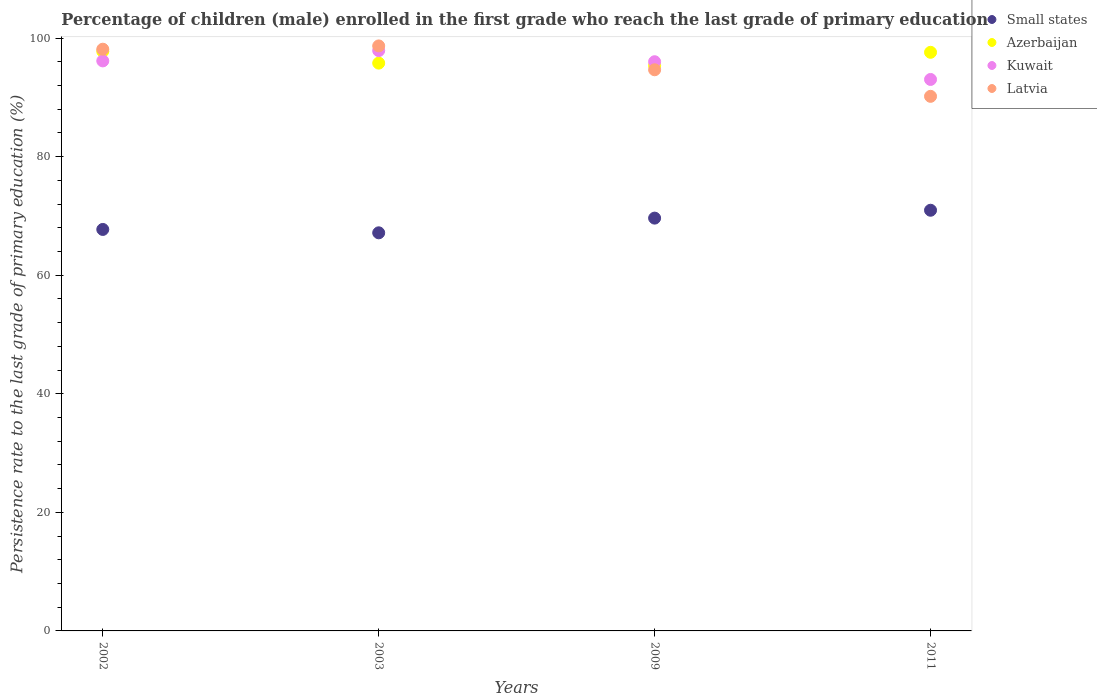Is the number of dotlines equal to the number of legend labels?
Offer a very short reply. Yes. What is the persistence rate of children in Kuwait in 2003?
Offer a terse response. 97.89. Across all years, what is the maximum persistence rate of children in Latvia?
Ensure brevity in your answer.  98.68. Across all years, what is the minimum persistence rate of children in Small states?
Your response must be concise. 67.15. In which year was the persistence rate of children in Azerbaijan maximum?
Ensure brevity in your answer.  2002. What is the total persistence rate of children in Azerbaijan in the graph?
Offer a terse response. 386.53. What is the difference between the persistence rate of children in Azerbaijan in 2002 and that in 2009?
Make the answer very short. 2.39. What is the difference between the persistence rate of children in Kuwait in 2002 and the persistence rate of children in Small states in 2009?
Your response must be concise. 26.52. What is the average persistence rate of children in Azerbaijan per year?
Offer a terse response. 96.63. In the year 2009, what is the difference between the persistence rate of children in Latvia and persistence rate of children in Kuwait?
Keep it short and to the point. -1.36. What is the ratio of the persistence rate of children in Azerbaijan in 2003 to that in 2009?
Ensure brevity in your answer.  1. Is the difference between the persistence rate of children in Latvia in 2002 and 2003 greater than the difference between the persistence rate of children in Kuwait in 2002 and 2003?
Offer a terse response. Yes. What is the difference between the highest and the second highest persistence rate of children in Kuwait?
Your answer should be compact. 1.74. What is the difference between the highest and the lowest persistence rate of children in Kuwait?
Your answer should be very brief. 4.87. In how many years, is the persistence rate of children in Small states greater than the average persistence rate of children in Small states taken over all years?
Your response must be concise. 2. Is the sum of the persistence rate of children in Kuwait in 2002 and 2003 greater than the maximum persistence rate of children in Latvia across all years?
Your answer should be compact. Yes. Is it the case that in every year, the sum of the persistence rate of children in Latvia and persistence rate of children in Azerbaijan  is greater than the sum of persistence rate of children in Kuwait and persistence rate of children in Small states?
Your answer should be very brief. No. Is it the case that in every year, the sum of the persistence rate of children in Kuwait and persistence rate of children in Latvia  is greater than the persistence rate of children in Small states?
Ensure brevity in your answer.  Yes. How many dotlines are there?
Give a very brief answer. 4. Are the values on the major ticks of Y-axis written in scientific E-notation?
Offer a very short reply. No. Does the graph contain any zero values?
Provide a succinct answer. No. How are the legend labels stacked?
Provide a short and direct response. Vertical. What is the title of the graph?
Your answer should be compact. Percentage of children (male) enrolled in the first grade who reach the last grade of primary education. Does "Slovenia" appear as one of the legend labels in the graph?
Give a very brief answer. No. What is the label or title of the Y-axis?
Give a very brief answer. Persistence rate to the last grade of primary education (%). What is the Persistence rate to the last grade of primary education (%) of Small states in 2002?
Provide a short and direct response. 67.72. What is the Persistence rate to the last grade of primary education (%) of Azerbaijan in 2002?
Your answer should be very brief. 97.77. What is the Persistence rate to the last grade of primary education (%) in Kuwait in 2002?
Offer a terse response. 96.15. What is the Persistence rate to the last grade of primary education (%) of Latvia in 2002?
Your answer should be compact. 98.13. What is the Persistence rate to the last grade of primary education (%) in Small states in 2003?
Provide a short and direct response. 67.15. What is the Persistence rate to the last grade of primary education (%) in Azerbaijan in 2003?
Your answer should be very brief. 95.78. What is the Persistence rate to the last grade of primary education (%) in Kuwait in 2003?
Your answer should be compact. 97.89. What is the Persistence rate to the last grade of primary education (%) in Latvia in 2003?
Offer a very short reply. 98.68. What is the Persistence rate to the last grade of primary education (%) of Small states in 2009?
Provide a succinct answer. 69.63. What is the Persistence rate to the last grade of primary education (%) in Azerbaijan in 2009?
Make the answer very short. 95.38. What is the Persistence rate to the last grade of primary education (%) of Kuwait in 2009?
Offer a very short reply. 96.02. What is the Persistence rate to the last grade of primary education (%) of Latvia in 2009?
Provide a succinct answer. 94.66. What is the Persistence rate to the last grade of primary education (%) of Small states in 2011?
Your answer should be compact. 70.96. What is the Persistence rate to the last grade of primary education (%) of Azerbaijan in 2011?
Provide a succinct answer. 97.6. What is the Persistence rate to the last grade of primary education (%) of Kuwait in 2011?
Offer a very short reply. 93.02. What is the Persistence rate to the last grade of primary education (%) of Latvia in 2011?
Ensure brevity in your answer.  90.18. Across all years, what is the maximum Persistence rate to the last grade of primary education (%) of Small states?
Give a very brief answer. 70.96. Across all years, what is the maximum Persistence rate to the last grade of primary education (%) in Azerbaijan?
Your answer should be very brief. 97.77. Across all years, what is the maximum Persistence rate to the last grade of primary education (%) in Kuwait?
Your answer should be compact. 97.89. Across all years, what is the maximum Persistence rate to the last grade of primary education (%) of Latvia?
Provide a short and direct response. 98.68. Across all years, what is the minimum Persistence rate to the last grade of primary education (%) of Small states?
Offer a very short reply. 67.15. Across all years, what is the minimum Persistence rate to the last grade of primary education (%) in Azerbaijan?
Provide a short and direct response. 95.38. Across all years, what is the minimum Persistence rate to the last grade of primary education (%) in Kuwait?
Give a very brief answer. 93.02. Across all years, what is the minimum Persistence rate to the last grade of primary education (%) in Latvia?
Ensure brevity in your answer.  90.18. What is the total Persistence rate to the last grade of primary education (%) in Small states in the graph?
Keep it short and to the point. 275.47. What is the total Persistence rate to the last grade of primary education (%) in Azerbaijan in the graph?
Ensure brevity in your answer.  386.53. What is the total Persistence rate to the last grade of primary education (%) of Kuwait in the graph?
Your answer should be compact. 383.08. What is the total Persistence rate to the last grade of primary education (%) in Latvia in the graph?
Offer a terse response. 381.64. What is the difference between the Persistence rate to the last grade of primary education (%) of Small states in 2002 and that in 2003?
Provide a succinct answer. 0.57. What is the difference between the Persistence rate to the last grade of primary education (%) in Azerbaijan in 2002 and that in 2003?
Ensure brevity in your answer.  1.99. What is the difference between the Persistence rate to the last grade of primary education (%) in Kuwait in 2002 and that in 2003?
Offer a very short reply. -1.74. What is the difference between the Persistence rate to the last grade of primary education (%) in Latvia in 2002 and that in 2003?
Keep it short and to the point. -0.55. What is the difference between the Persistence rate to the last grade of primary education (%) of Small states in 2002 and that in 2009?
Your answer should be very brief. -1.91. What is the difference between the Persistence rate to the last grade of primary education (%) in Azerbaijan in 2002 and that in 2009?
Offer a terse response. 2.39. What is the difference between the Persistence rate to the last grade of primary education (%) of Kuwait in 2002 and that in 2009?
Your answer should be very brief. 0.14. What is the difference between the Persistence rate to the last grade of primary education (%) in Latvia in 2002 and that in 2009?
Offer a terse response. 3.47. What is the difference between the Persistence rate to the last grade of primary education (%) in Small states in 2002 and that in 2011?
Your answer should be compact. -3.24. What is the difference between the Persistence rate to the last grade of primary education (%) in Azerbaijan in 2002 and that in 2011?
Offer a very short reply. 0.16. What is the difference between the Persistence rate to the last grade of primary education (%) in Kuwait in 2002 and that in 2011?
Provide a succinct answer. 3.13. What is the difference between the Persistence rate to the last grade of primary education (%) of Latvia in 2002 and that in 2011?
Offer a very short reply. 7.95. What is the difference between the Persistence rate to the last grade of primary education (%) of Small states in 2003 and that in 2009?
Your answer should be very brief. -2.48. What is the difference between the Persistence rate to the last grade of primary education (%) in Azerbaijan in 2003 and that in 2009?
Provide a succinct answer. 0.4. What is the difference between the Persistence rate to the last grade of primary education (%) of Kuwait in 2003 and that in 2009?
Offer a very short reply. 1.87. What is the difference between the Persistence rate to the last grade of primary education (%) of Latvia in 2003 and that in 2009?
Your answer should be very brief. 4.02. What is the difference between the Persistence rate to the last grade of primary education (%) of Small states in 2003 and that in 2011?
Make the answer very short. -3.81. What is the difference between the Persistence rate to the last grade of primary education (%) in Azerbaijan in 2003 and that in 2011?
Your answer should be compact. -1.82. What is the difference between the Persistence rate to the last grade of primary education (%) of Kuwait in 2003 and that in 2011?
Keep it short and to the point. 4.87. What is the difference between the Persistence rate to the last grade of primary education (%) of Latvia in 2003 and that in 2011?
Make the answer very short. 8.5. What is the difference between the Persistence rate to the last grade of primary education (%) of Small states in 2009 and that in 2011?
Your response must be concise. -1.33. What is the difference between the Persistence rate to the last grade of primary education (%) of Azerbaijan in 2009 and that in 2011?
Make the answer very short. -2.22. What is the difference between the Persistence rate to the last grade of primary education (%) in Kuwait in 2009 and that in 2011?
Your response must be concise. 2.99. What is the difference between the Persistence rate to the last grade of primary education (%) of Latvia in 2009 and that in 2011?
Make the answer very short. 4.48. What is the difference between the Persistence rate to the last grade of primary education (%) of Small states in 2002 and the Persistence rate to the last grade of primary education (%) of Azerbaijan in 2003?
Give a very brief answer. -28.06. What is the difference between the Persistence rate to the last grade of primary education (%) of Small states in 2002 and the Persistence rate to the last grade of primary education (%) of Kuwait in 2003?
Offer a terse response. -30.17. What is the difference between the Persistence rate to the last grade of primary education (%) of Small states in 2002 and the Persistence rate to the last grade of primary education (%) of Latvia in 2003?
Provide a succinct answer. -30.96. What is the difference between the Persistence rate to the last grade of primary education (%) in Azerbaijan in 2002 and the Persistence rate to the last grade of primary education (%) in Kuwait in 2003?
Your answer should be compact. -0.12. What is the difference between the Persistence rate to the last grade of primary education (%) in Azerbaijan in 2002 and the Persistence rate to the last grade of primary education (%) in Latvia in 2003?
Provide a succinct answer. -0.91. What is the difference between the Persistence rate to the last grade of primary education (%) of Kuwait in 2002 and the Persistence rate to the last grade of primary education (%) of Latvia in 2003?
Provide a short and direct response. -2.53. What is the difference between the Persistence rate to the last grade of primary education (%) of Small states in 2002 and the Persistence rate to the last grade of primary education (%) of Azerbaijan in 2009?
Provide a succinct answer. -27.66. What is the difference between the Persistence rate to the last grade of primary education (%) in Small states in 2002 and the Persistence rate to the last grade of primary education (%) in Kuwait in 2009?
Provide a succinct answer. -28.29. What is the difference between the Persistence rate to the last grade of primary education (%) in Small states in 2002 and the Persistence rate to the last grade of primary education (%) in Latvia in 2009?
Your answer should be compact. -26.93. What is the difference between the Persistence rate to the last grade of primary education (%) in Azerbaijan in 2002 and the Persistence rate to the last grade of primary education (%) in Kuwait in 2009?
Offer a very short reply. 1.75. What is the difference between the Persistence rate to the last grade of primary education (%) of Azerbaijan in 2002 and the Persistence rate to the last grade of primary education (%) of Latvia in 2009?
Provide a short and direct response. 3.11. What is the difference between the Persistence rate to the last grade of primary education (%) of Kuwait in 2002 and the Persistence rate to the last grade of primary education (%) of Latvia in 2009?
Offer a terse response. 1.5. What is the difference between the Persistence rate to the last grade of primary education (%) in Small states in 2002 and the Persistence rate to the last grade of primary education (%) in Azerbaijan in 2011?
Ensure brevity in your answer.  -29.88. What is the difference between the Persistence rate to the last grade of primary education (%) of Small states in 2002 and the Persistence rate to the last grade of primary education (%) of Kuwait in 2011?
Make the answer very short. -25.3. What is the difference between the Persistence rate to the last grade of primary education (%) of Small states in 2002 and the Persistence rate to the last grade of primary education (%) of Latvia in 2011?
Your answer should be very brief. -22.45. What is the difference between the Persistence rate to the last grade of primary education (%) of Azerbaijan in 2002 and the Persistence rate to the last grade of primary education (%) of Kuwait in 2011?
Ensure brevity in your answer.  4.74. What is the difference between the Persistence rate to the last grade of primary education (%) of Azerbaijan in 2002 and the Persistence rate to the last grade of primary education (%) of Latvia in 2011?
Give a very brief answer. 7.59. What is the difference between the Persistence rate to the last grade of primary education (%) in Kuwait in 2002 and the Persistence rate to the last grade of primary education (%) in Latvia in 2011?
Your response must be concise. 5.98. What is the difference between the Persistence rate to the last grade of primary education (%) of Small states in 2003 and the Persistence rate to the last grade of primary education (%) of Azerbaijan in 2009?
Offer a very short reply. -28.23. What is the difference between the Persistence rate to the last grade of primary education (%) in Small states in 2003 and the Persistence rate to the last grade of primary education (%) in Kuwait in 2009?
Offer a terse response. -28.86. What is the difference between the Persistence rate to the last grade of primary education (%) of Small states in 2003 and the Persistence rate to the last grade of primary education (%) of Latvia in 2009?
Provide a short and direct response. -27.5. What is the difference between the Persistence rate to the last grade of primary education (%) of Azerbaijan in 2003 and the Persistence rate to the last grade of primary education (%) of Kuwait in 2009?
Offer a very short reply. -0.24. What is the difference between the Persistence rate to the last grade of primary education (%) of Azerbaijan in 2003 and the Persistence rate to the last grade of primary education (%) of Latvia in 2009?
Offer a very short reply. 1.12. What is the difference between the Persistence rate to the last grade of primary education (%) in Kuwait in 2003 and the Persistence rate to the last grade of primary education (%) in Latvia in 2009?
Keep it short and to the point. 3.23. What is the difference between the Persistence rate to the last grade of primary education (%) of Small states in 2003 and the Persistence rate to the last grade of primary education (%) of Azerbaijan in 2011?
Give a very brief answer. -30.45. What is the difference between the Persistence rate to the last grade of primary education (%) of Small states in 2003 and the Persistence rate to the last grade of primary education (%) of Kuwait in 2011?
Ensure brevity in your answer.  -25.87. What is the difference between the Persistence rate to the last grade of primary education (%) in Small states in 2003 and the Persistence rate to the last grade of primary education (%) in Latvia in 2011?
Keep it short and to the point. -23.02. What is the difference between the Persistence rate to the last grade of primary education (%) in Azerbaijan in 2003 and the Persistence rate to the last grade of primary education (%) in Kuwait in 2011?
Your response must be concise. 2.76. What is the difference between the Persistence rate to the last grade of primary education (%) in Azerbaijan in 2003 and the Persistence rate to the last grade of primary education (%) in Latvia in 2011?
Your answer should be compact. 5.6. What is the difference between the Persistence rate to the last grade of primary education (%) of Kuwait in 2003 and the Persistence rate to the last grade of primary education (%) of Latvia in 2011?
Offer a terse response. 7.71. What is the difference between the Persistence rate to the last grade of primary education (%) in Small states in 2009 and the Persistence rate to the last grade of primary education (%) in Azerbaijan in 2011?
Offer a very short reply. -27.97. What is the difference between the Persistence rate to the last grade of primary education (%) of Small states in 2009 and the Persistence rate to the last grade of primary education (%) of Kuwait in 2011?
Your answer should be very brief. -23.39. What is the difference between the Persistence rate to the last grade of primary education (%) in Small states in 2009 and the Persistence rate to the last grade of primary education (%) in Latvia in 2011?
Your response must be concise. -20.54. What is the difference between the Persistence rate to the last grade of primary education (%) of Azerbaijan in 2009 and the Persistence rate to the last grade of primary education (%) of Kuwait in 2011?
Give a very brief answer. 2.35. What is the difference between the Persistence rate to the last grade of primary education (%) in Azerbaijan in 2009 and the Persistence rate to the last grade of primary education (%) in Latvia in 2011?
Ensure brevity in your answer.  5.2. What is the difference between the Persistence rate to the last grade of primary education (%) in Kuwait in 2009 and the Persistence rate to the last grade of primary education (%) in Latvia in 2011?
Provide a short and direct response. 5.84. What is the average Persistence rate to the last grade of primary education (%) of Small states per year?
Make the answer very short. 68.87. What is the average Persistence rate to the last grade of primary education (%) in Azerbaijan per year?
Ensure brevity in your answer.  96.63. What is the average Persistence rate to the last grade of primary education (%) of Kuwait per year?
Ensure brevity in your answer.  95.77. What is the average Persistence rate to the last grade of primary education (%) in Latvia per year?
Ensure brevity in your answer.  95.41. In the year 2002, what is the difference between the Persistence rate to the last grade of primary education (%) of Small states and Persistence rate to the last grade of primary education (%) of Azerbaijan?
Your answer should be very brief. -30.04. In the year 2002, what is the difference between the Persistence rate to the last grade of primary education (%) of Small states and Persistence rate to the last grade of primary education (%) of Kuwait?
Ensure brevity in your answer.  -28.43. In the year 2002, what is the difference between the Persistence rate to the last grade of primary education (%) in Small states and Persistence rate to the last grade of primary education (%) in Latvia?
Keep it short and to the point. -30.4. In the year 2002, what is the difference between the Persistence rate to the last grade of primary education (%) in Azerbaijan and Persistence rate to the last grade of primary education (%) in Kuwait?
Provide a short and direct response. 1.61. In the year 2002, what is the difference between the Persistence rate to the last grade of primary education (%) of Azerbaijan and Persistence rate to the last grade of primary education (%) of Latvia?
Offer a very short reply. -0.36. In the year 2002, what is the difference between the Persistence rate to the last grade of primary education (%) of Kuwait and Persistence rate to the last grade of primary education (%) of Latvia?
Offer a terse response. -1.97. In the year 2003, what is the difference between the Persistence rate to the last grade of primary education (%) in Small states and Persistence rate to the last grade of primary education (%) in Azerbaijan?
Provide a short and direct response. -28.63. In the year 2003, what is the difference between the Persistence rate to the last grade of primary education (%) of Small states and Persistence rate to the last grade of primary education (%) of Kuwait?
Provide a succinct answer. -30.74. In the year 2003, what is the difference between the Persistence rate to the last grade of primary education (%) in Small states and Persistence rate to the last grade of primary education (%) in Latvia?
Your response must be concise. -31.53. In the year 2003, what is the difference between the Persistence rate to the last grade of primary education (%) of Azerbaijan and Persistence rate to the last grade of primary education (%) of Kuwait?
Keep it short and to the point. -2.11. In the year 2003, what is the difference between the Persistence rate to the last grade of primary education (%) in Azerbaijan and Persistence rate to the last grade of primary education (%) in Latvia?
Provide a short and direct response. -2.9. In the year 2003, what is the difference between the Persistence rate to the last grade of primary education (%) in Kuwait and Persistence rate to the last grade of primary education (%) in Latvia?
Offer a very short reply. -0.79. In the year 2009, what is the difference between the Persistence rate to the last grade of primary education (%) in Small states and Persistence rate to the last grade of primary education (%) in Azerbaijan?
Your response must be concise. -25.75. In the year 2009, what is the difference between the Persistence rate to the last grade of primary education (%) of Small states and Persistence rate to the last grade of primary education (%) of Kuwait?
Your response must be concise. -26.38. In the year 2009, what is the difference between the Persistence rate to the last grade of primary education (%) of Small states and Persistence rate to the last grade of primary education (%) of Latvia?
Provide a succinct answer. -25.02. In the year 2009, what is the difference between the Persistence rate to the last grade of primary education (%) in Azerbaijan and Persistence rate to the last grade of primary education (%) in Kuwait?
Ensure brevity in your answer.  -0.64. In the year 2009, what is the difference between the Persistence rate to the last grade of primary education (%) in Azerbaijan and Persistence rate to the last grade of primary education (%) in Latvia?
Your answer should be very brief. 0.72. In the year 2009, what is the difference between the Persistence rate to the last grade of primary education (%) of Kuwait and Persistence rate to the last grade of primary education (%) of Latvia?
Keep it short and to the point. 1.36. In the year 2011, what is the difference between the Persistence rate to the last grade of primary education (%) of Small states and Persistence rate to the last grade of primary education (%) of Azerbaijan?
Give a very brief answer. -26.64. In the year 2011, what is the difference between the Persistence rate to the last grade of primary education (%) in Small states and Persistence rate to the last grade of primary education (%) in Kuwait?
Keep it short and to the point. -22.06. In the year 2011, what is the difference between the Persistence rate to the last grade of primary education (%) of Small states and Persistence rate to the last grade of primary education (%) of Latvia?
Your answer should be very brief. -19.22. In the year 2011, what is the difference between the Persistence rate to the last grade of primary education (%) of Azerbaijan and Persistence rate to the last grade of primary education (%) of Kuwait?
Offer a very short reply. 4.58. In the year 2011, what is the difference between the Persistence rate to the last grade of primary education (%) of Azerbaijan and Persistence rate to the last grade of primary education (%) of Latvia?
Ensure brevity in your answer.  7.43. In the year 2011, what is the difference between the Persistence rate to the last grade of primary education (%) in Kuwait and Persistence rate to the last grade of primary education (%) in Latvia?
Ensure brevity in your answer.  2.85. What is the ratio of the Persistence rate to the last grade of primary education (%) of Small states in 2002 to that in 2003?
Ensure brevity in your answer.  1.01. What is the ratio of the Persistence rate to the last grade of primary education (%) of Azerbaijan in 2002 to that in 2003?
Provide a short and direct response. 1.02. What is the ratio of the Persistence rate to the last grade of primary education (%) of Kuwait in 2002 to that in 2003?
Provide a short and direct response. 0.98. What is the ratio of the Persistence rate to the last grade of primary education (%) of Small states in 2002 to that in 2009?
Ensure brevity in your answer.  0.97. What is the ratio of the Persistence rate to the last grade of primary education (%) in Azerbaijan in 2002 to that in 2009?
Your response must be concise. 1.02. What is the ratio of the Persistence rate to the last grade of primary education (%) in Kuwait in 2002 to that in 2009?
Give a very brief answer. 1. What is the ratio of the Persistence rate to the last grade of primary education (%) in Latvia in 2002 to that in 2009?
Make the answer very short. 1.04. What is the ratio of the Persistence rate to the last grade of primary education (%) in Small states in 2002 to that in 2011?
Your response must be concise. 0.95. What is the ratio of the Persistence rate to the last grade of primary education (%) in Azerbaijan in 2002 to that in 2011?
Offer a terse response. 1. What is the ratio of the Persistence rate to the last grade of primary education (%) of Kuwait in 2002 to that in 2011?
Make the answer very short. 1.03. What is the ratio of the Persistence rate to the last grade of primary education (%) of Latvia in 2002 to that in 2011?
Give a very brief answer. 1.09. What is the ratio of the Persistence rate to the last grade of primary education (%) of Small states in 2003 to that in 2009?
Give a very brief answer. 0.96. What is the ratio of the Persistence rate to the last grade of primary education (%) of Kuwait in 2003 to that in 2009?
Keep it short and to the point. 1.02. What is the ratio of the Persistence rate to the last grade of primary education (%) in Latvia in 2003 to that in 2009?
Keep it short and to the point. 1.04. What is the ratio of the Persistence rate to the last grade of primary education (%) in Small states in 2003 to that in 2011?
Provide a short and direct response. 0.95. What is the ratio of the Persistence rate to the last grade of primary education (%) of Azerbaijan in 2003 to that in 2011?
Offer a terse response. 0.98. What is the ratio of the Persistence rate to the last grade of primary education (%) of Kuwait in 2003 to that in 2011?
Offer a terse response. 1.05. What is the ratio of the Persistence rate to the last grade of primary education (%) in Latvia in 2003 to that in 2011?
Give a very brief answer. 1.09. What is the ratio of the Persistence rate to the last grade of primary education (%) in Small states in 2009 to that in 2011?
Your response must be concise. 0.98. What is the ratio of the Persistence rate to the last grade of primary education (%) in Azerbaijan in 2009 to that in 2011?
Your answer should be compact. 0.98. What is the ratio of the Persistence rate to the last grade of primary education (%) in Kuwait in 2009 to that in 2011?
Your answer should be compact. 1.03. What is the ratio of the Persistence rate to the last grade of primary education (%) of Latvia in 2009 to that in 2011?
Provide a succinct answer. 1.05. What is the difference between the highest and the second highest Persistence rate to the last grade of primary education (%) of Small states?
Ensure brevity in your answer.  1.33. What is the difference between the highest and the second highest Persistence rate to the last grade of primary education (%) in Azerbaijan?
Provide a succinct answer. 0.16. What is the difference between the highest and the second highest Persistence rate to the last grade of primary education (%) of Kuwait?
Your answer should be very brief. 1.74. What is the difference between the highest and the second highest Persistence rate to the last grade of primary education (%) in Latvia?
Your answer should be very brief. 0.55. What is the difference between the highest and the lowest Persistence rate to the last grade of primary education (%) in Small states?
Your answer should be very brief. 3.81. What is the difference between the highest and the lowest Persistence rate to the last grade of primary education (%) of Azerbaijan?
Ensure brevity in your answer.  2.39. What is the difference between the highest and the lowest Persistence rate to the last grade of primary education (%) in Kuwait?
Ensure brevity in your answer.  4.87. What is the difference between the highest and the lowest Persistence rate to the last grade of primary education (%) in Latvia?
Your answer should be compact. 8.5. 